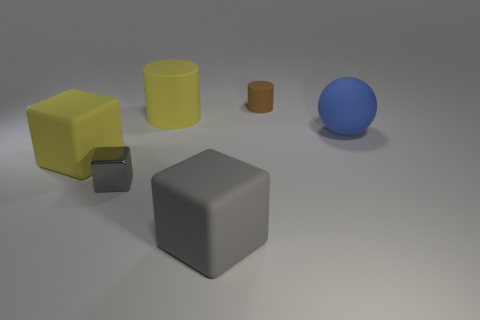Are there any other things that are made of the same material as the tiny gray thing?
Offer a terse response. No. There is a large object that is the same color as the small cube; what is its material?
Keep it short and to the point. Rubber. Is there a cube that has the same material as the ball?
Keep it short and to the point. Yes. There is a yellow thing in front of the blue sphere; does it have the same size as the brown rubber object?
Your answer should be compact. No. Are there any yellow cylinders right of the yellow object to the right of the rubber block that is behind the gray metal object?
Your answer should be compact. No. What number of matte things are either gray cubes or tiny gray things?
Your response must be concise. 1. What number of other objects are there of the same shape as the tiny gray thing?
Keep it short and to the point. 2. Are there more big spheres than big gray shiny cylinders?
Ensure brevity in your answer.  Yes. How big is the brown rubber thing behind the gray thing to the left of the large object in front of the large yellow block?
Ensure brevity in your answer.  Small. There is a cylinder right of the big cylinder; what size is it?
Make the answer very short. Small. 